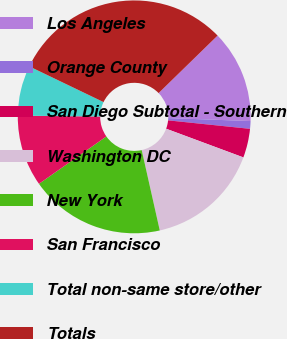Convert chart to OTSL. <chart><loc_0><loc_0><loc_500><loc_500><pie_chart><fcel>Los Angeles<fcel>Orange County<fcel>San Diego Subtotal - Southern<fcel>Washington DC<fcel>New York<fcel>San Francisco<fcel>Total non-same store/other<fcel>Totals<nl><fcel>12.87%<fcel>1.07%<fcel>4.02%<fcel>15.82%<fcel>18.77%<fcel>9.92%<fcel>6.97%<fcel>30.57%<nl></chart> 